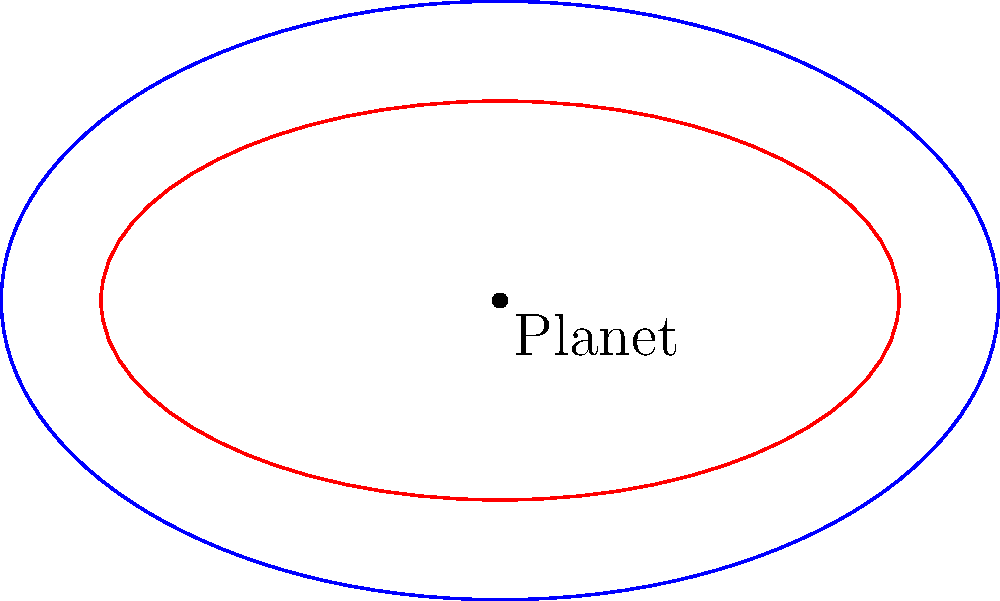In the Enderverse, two small ships are orbiting a planet in elliptical paths. The orbits can be modeled by the equations $\frac{x^2}{25} + \frac{y^2}{9} = 1$ (blue) and $\frac{x^2}{16} + \frac{y^2}{4} = 1$ (red), where distances are measured in thousands of kilometers. At what points do these orbits intersect, potentially allowing for a rendezvous between the ships? To find the intersection points of these two ellipses, we need to solve the system of equations:

1) $\frac{x^2}{25} + \frac{y^2}{9} = 1$
2) $\frac{x^2}{16} + \frac{y^2}{4} = 1$

Step 1: Multiply equation (1) by 36 and equation (2) by 16:
   $\frac{36x^2}{25} + 4y^2 = 36$
   $x^2 + 4y^2 = 16$

Step 2: Subtract the second equation from the first:
   $\frac{36x^2}{25} - x^2 = 36 - 16$
   $\frac{11x^2}{25} = 20$

Step 3: Solve for $x^2$:
   $x^2 = \frac{500}{11} \approx 45.45$

Step 4: Find $x$ values:
   $x = \pm \sqrt{\frac{500}{11}} \approx \pm 6.74$

Step 5: Substitute these $x$ values into equation (2) to find $y$:
   $\frac{(\pm 6.74)^2}{16} + \frac{y^2}{4} = 1$
   $\frac{y^2}{4} = 1 - \frac{45.45}{16} \approx 0.16$
   $y^2 \approx 0.64$
   $y \approx \pm 0.8$

Therefore, the intersection points are approximately (6.74, 0.8), (6.74, -0.8), (-6.74, 0.8), and (-6.74, -0.8).
Answer: (±6.74, ±0.8) 